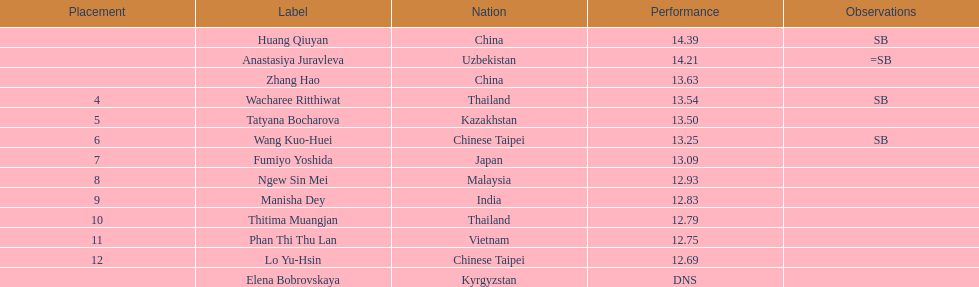How long was manisha dey's jump? 12.83. 